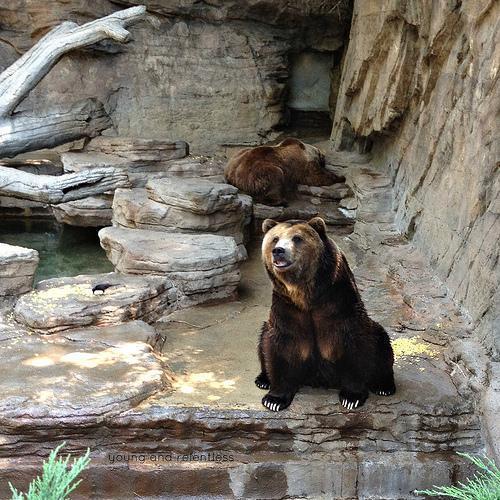How many bears are there?
Give a very brief answer. 2. 